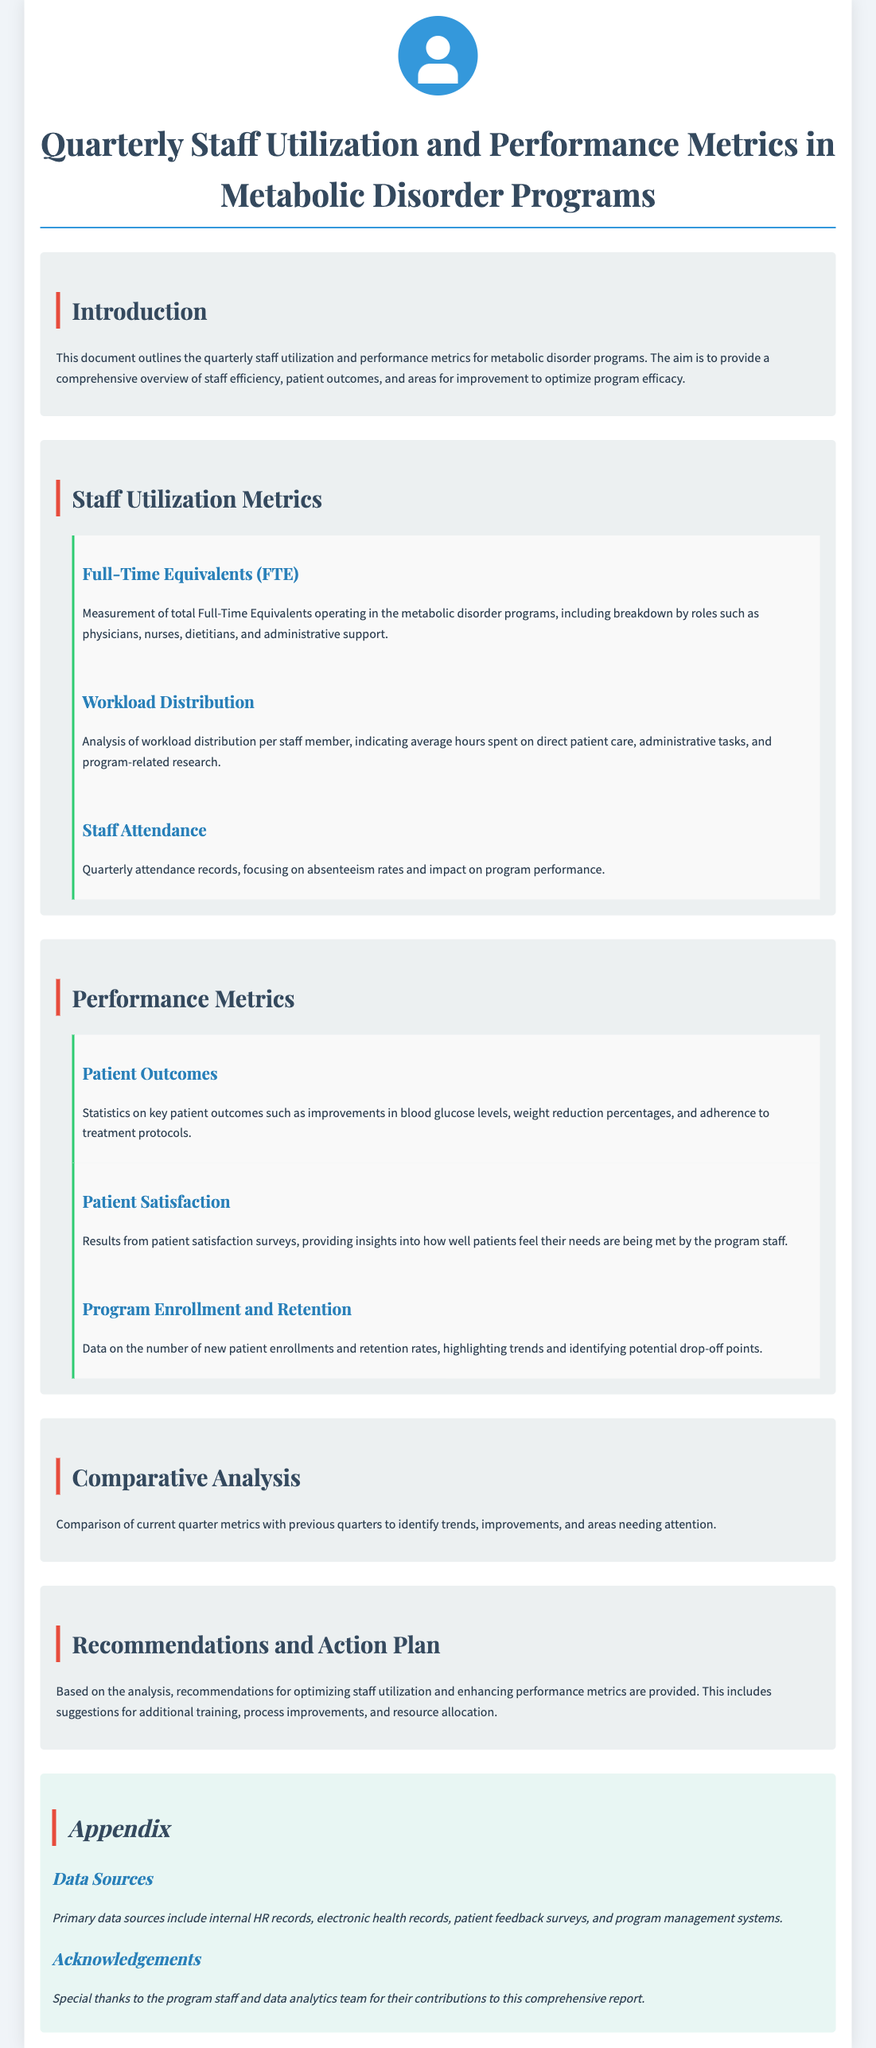What is the main purpose of the document? The document outlines quarterly staff utilization and performance metrics for metabolic disorder programs, aiming to provide a comprehensive overview of staff efficiency, patient outcomes, and areas for improvement.
Answer: Comprehensive overview What section describes workload distribution? The section that details the analysis of workload distribution per staff member, including average hours on various tasks.
Answer: Staff Utilization Metrics What does FTE stand for? The acronym used in the document to represent Full-Time Equivalents in the metabolic disorder programs.
Answer: Full-Time Equivalents What metric is analyzed in terms of improvements in blood glucose levels? The specific performance metric that looks at statistics regarding patient outcomes related to blood glucose improvements.
Answer: Patient Outcomes In which section would you find recommendations for enhancing performance metrics? This section contains suggestions based on analysis for optimizing staff utilization and performance metrics.
Answer: Recommendations and Action Plan What data sources are mentioned in the appendix? The primary data sources used for the report, including HR records and patient feedback surveys.
Answer: Internal HR records, electronic health records, patient feedback surveys, program management systems What is one focus of the staff attendance metrics? The key aspect related to attendance records that impacts the overall performance of the metabolic disorder program.
Answer: Absenteeism rates What is compared in the Comparative Analysis section? This section contrasts current quarter metrics with past quarters to highlight trends and areas needing attention.
Answer: Current quarter metrics with previous quarters What type of survey results are included in the performance metrics? The survey results that provide insight into how patients perceive the program staff's performance in meeting their needs.
Answer: Patient satisfaction surveys 